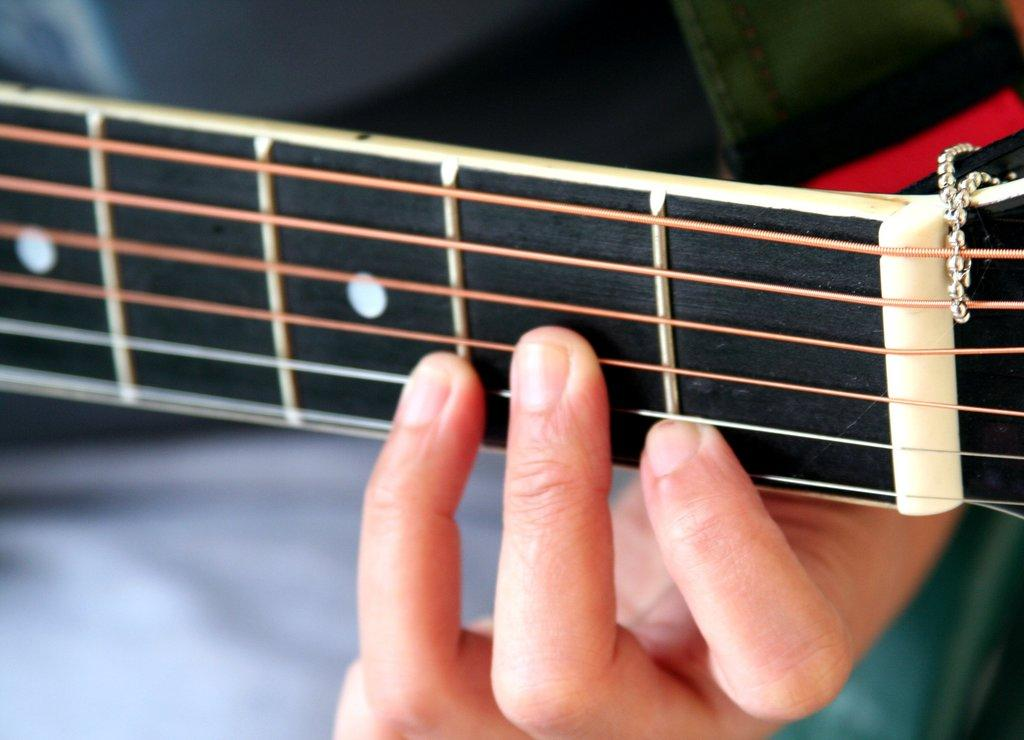What is the person holding in the image? There is a hand holding a guitar in the image. What part of the guitar can be seen? The neck of the guitar is visible. Are there any additional decorations on the guitar? Yes, there are beads hanging from the guitar. Can you describe the background of the image? There appears to be a person in the background of the image. What type of wool is being used to knit the robin's hat in the image? There is no robin or hat present in the image; it features a hand holding a guitar with beads hanging from it. 